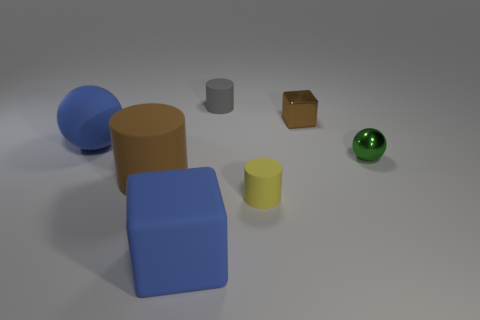What material is the block that is in front of the tiny cylinder in front of the tiny gray cylinder?
Make the answer very short. Rubber. How many shiny things are either large things or blocks?
Provide a succinct answer. 1. Are there any other things that have the same material as the big blue ball?
Keep it short and to the point. Yes. There is a brown object in front of the tiny green shiny ball; are there any green balls in front of it?
Your response must be concise. No. What number of objects are either small rubber things that are behind the green metal object or matte objects that are behind the small ball?
Your answer should be compact. 2. Are there any other things of the same color as the tiny metallic cube?
Provide a short and direct response. Yes. There is a small cylinder that is behind the brown object that is right of the tiny cylinder behind the small green sphere; what is its color?
Your response must be concise. Gray. There is a blue thing left of the brown thing in front of the brown shiny cube; how big is it?
Ensure brevity in your answer.  Large. The object that is behind the green metal object and to the left of the small gray matte thing is made of what material?
Provide a succinct answer. Rubber. There is a green sphere; is its size the same as the blue object behind the blue block?
Your response must be concise. No. 